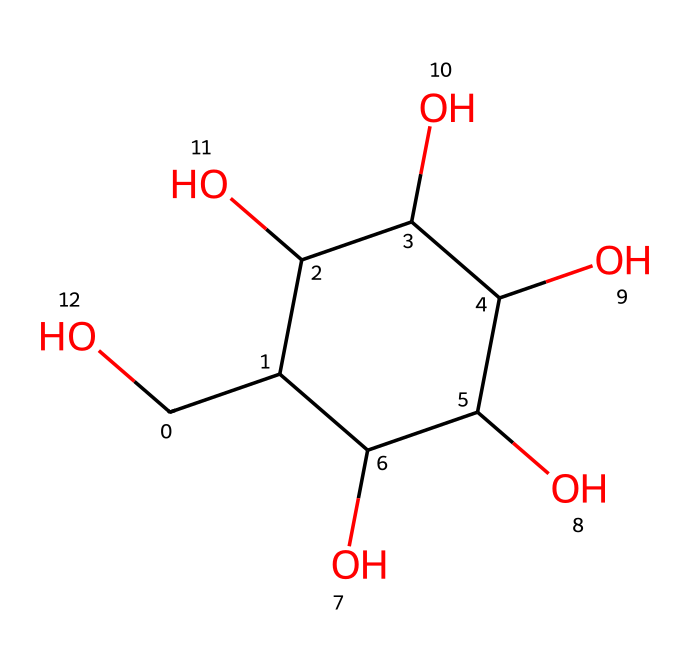What is the molecular formula of glucose? The SMILES representation indicates six carbon atoms (C), twelve hydrogen atoms (H), and six oxygen atoms (O), which gives the molecular formula C6H12O6.
Answer: C6H12O6 How many hydroxyl (-OH) groups are present in this molecule? By examining the structure through the SMILES, there are five -OH groups indicated, which are attached to carbon atoms in the cyclic form of glucose.
Answer: five What is the total number of carbon atoms in glucose? The molecule contains six carbon atoms as deduced from the structure visualized in the SMILES representation.
Answer: six Is glucose an aldehyde or a ketone? The structure of glucose reveals that it has an aldehyde group as part of its cyclic structure, which confirms it to be an aldehyde.
Answer: aldehyde Which type of isomerism is exhibited by glucose? Glucose exists in different structural forms, suggesting it displays stereoisomerism due to the presence of multiple chiral centers in its structure.
Answer: stereoisomerism How does glucose serve in cognitive functions? Glucose acts as a primary energy source for the brain, evidenced by its central role in powering cognitive functions and overall metabolism.
Answer: energy source What type of carbohydrate is glucose classified as? Given its structure and properties, glucose is classified as a monosaccharide, which is a simple sugar.
Answer: monosaccharide 